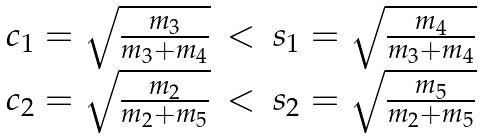Convert formula to latex. <formula><loc_0><loc_0><loc_500><loc_500>\begin{array} { l c l } c _ { 1 } = \sqrt { \frac { m _ { 3 } } { m _ { 3 } + m _ { 4 } } } & < & s _ { 1 } = \sqrt { \frac { m _ { 4 } } { m _ { 3 } + m _ { 4 } } } \\ c _ { 2 } = \sqrt { \frac { m _ { 2 } } { m _ { 2 } + m _ { 5 } } } & < & s _ { 2 } = \sqrt { \frac { m _ { 5 } } { m _ { 2 } + m _ { 5 } } } \end{array}</formula> 